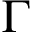<formula> <loc_0><loc_0><loc_500><loc_500>\Gamma</formula> 